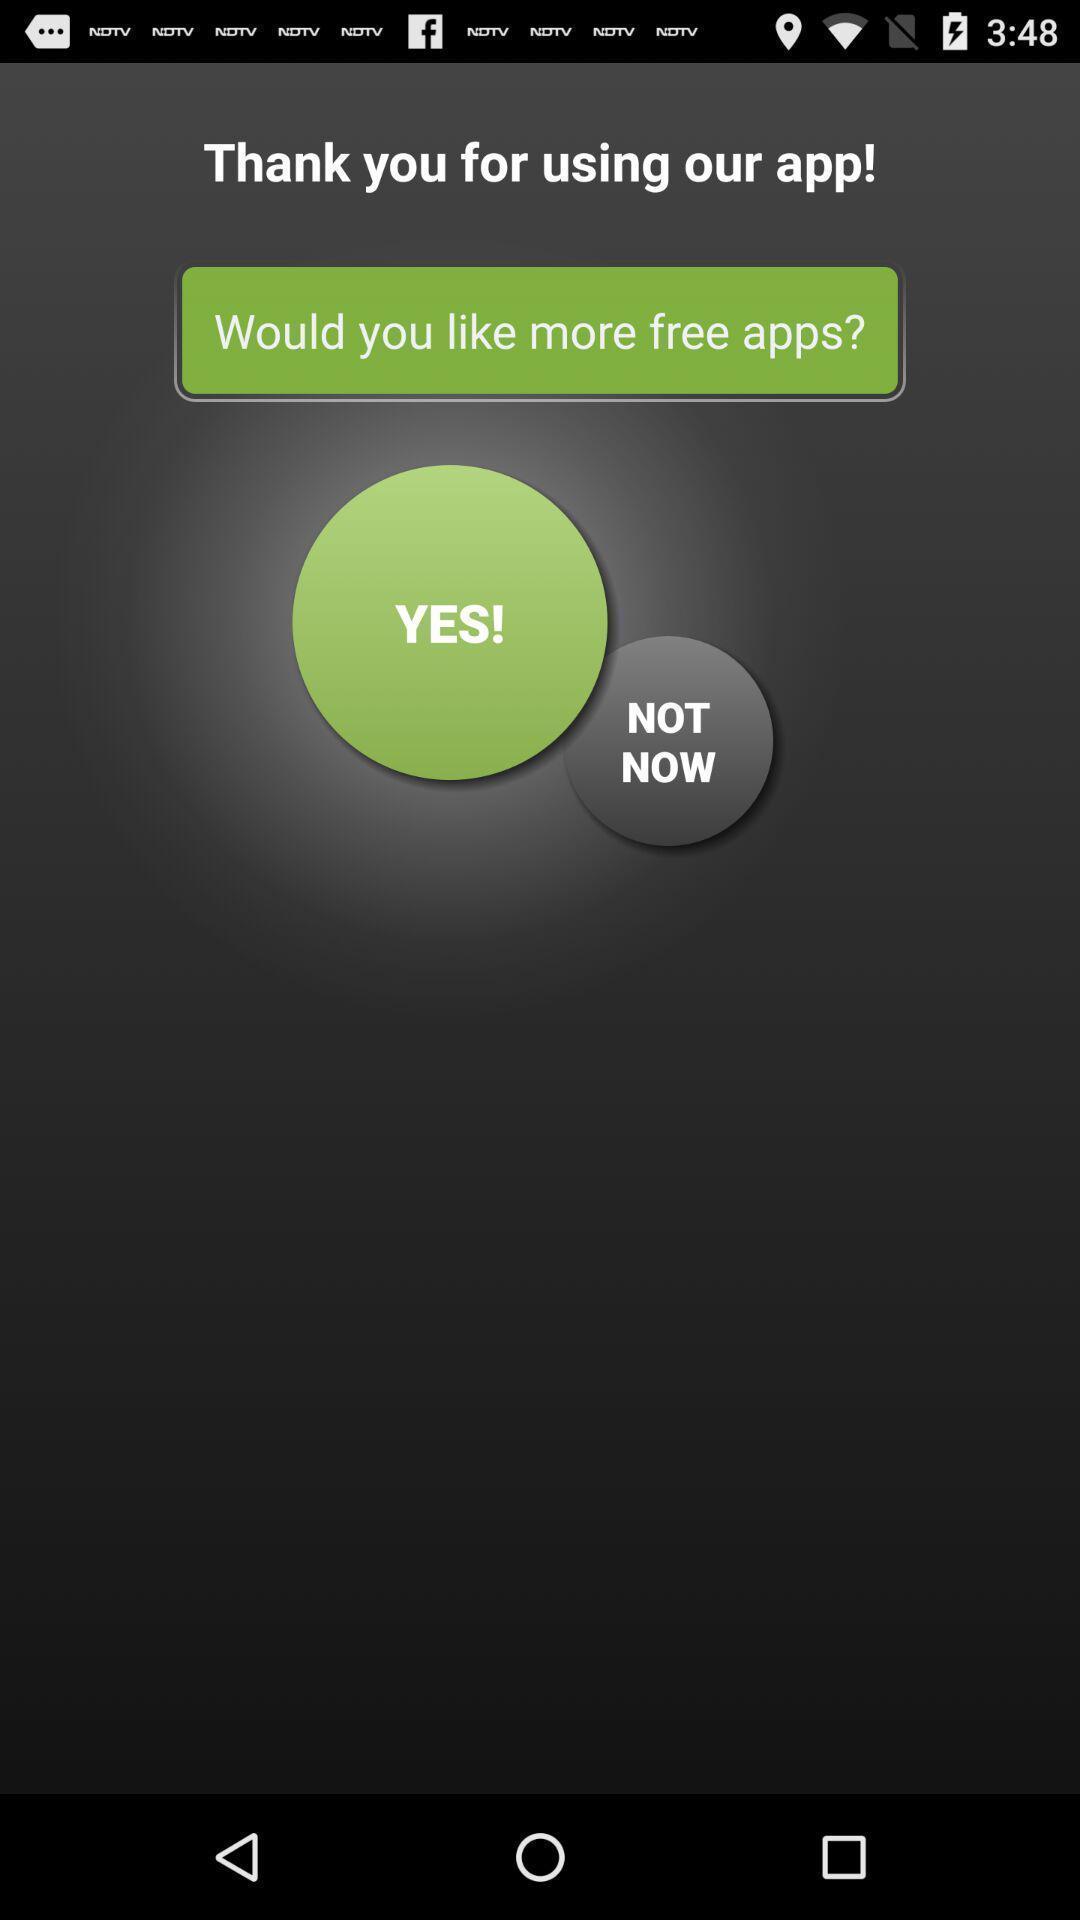Summarize the information in this screenshot. Screen shows multiple options in a news application. 